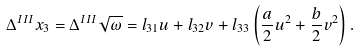<formula> <loc_0><loc_0><loc_500><loc_500>\Delta ^ { I I I } x _ { 3 } = \Delta ^ { I I I } \sqrt { \omega } = l _ { 3 1 } u + l _ { 3 2 } v + l _ { 3 3 } \left ( \frac { a } { 2 } u ^ { 2 } + \frac { b } { 2 } v ^ { 2 } \right ) .</formula> 